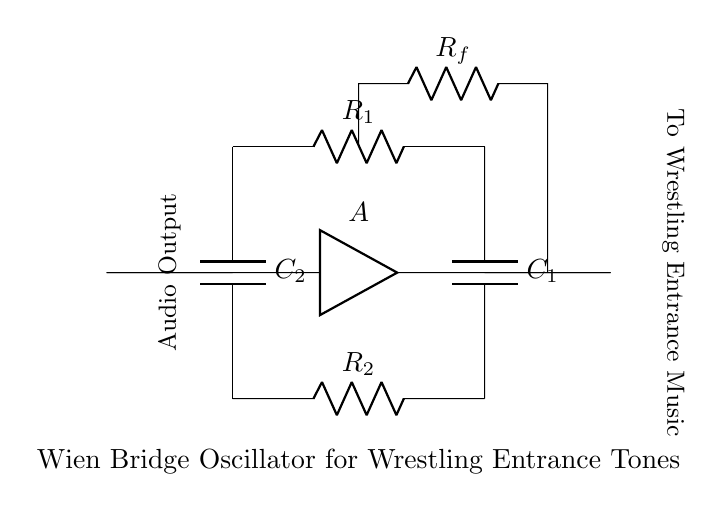What type of oscillator is depicted in the circuit? The diagram represents a Wien Bridge Oscillator, which is indicated by the arrangement of resistors and capacitors organized in a bridge configuration designed for generating audio frequencies.
Answer: Wien Bridge Oscillator What is the function of the audio output in this circuit? The audio output transmits the generated audio tones, which will be utilized for wrestling entrance music, as specified in the circuit's label.
Answer: Generate audio tones How many resistors are present in the circuit? There are three resistors present: R1, R2, and Rf, all of which are crucial for the functioning of the Wien Bridge Oscillator.
Answer: Three What components are involved in determining the oscillator frequency? The frequency of the oscillator is determined by the values of the resistors R1, R2, and the capacitors C1 and C2, as the combination defines the timing characteristics of the oscillator.
Answer: R1, R2, C1, C2 How is the amplifier represented in the circuit? The amplifier is depicted by a triangle symbol labeled "A," indicating its role in boosting the signal and maintaining oscillation in the circuit.
Answer: Amplifier What connects the audio output to wrestling entrance music? The audio output line connects via a short to the designated line marked "To Wrestling Entrance Music," indicating that the output tone is directed to the entrance music system.
Answer: Short connection 